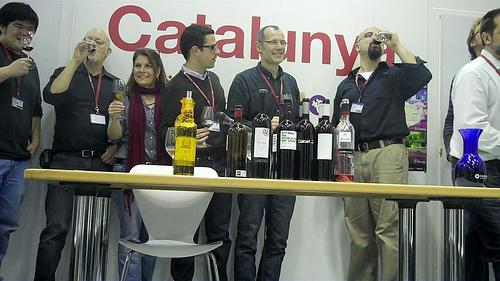What animal name does the first three letters on the wall spell? Please explain your reasoning. cat. The first two letters are "c" and "a". 